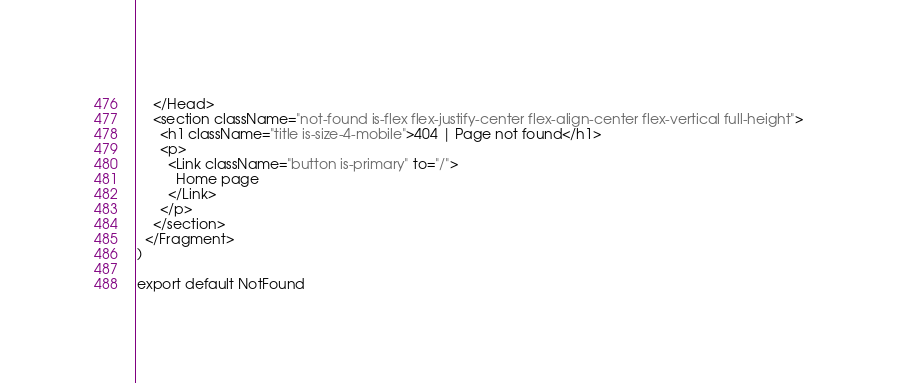<code> <loc_0><loc_0><loc_500><loc_500><_JavaScript_>    </Head>
    <section className="not-found is-flex flex-justify-center flex-align-center flex-vertical full-height">
      <h1 className="title is-size-4-mobile">404 | Page not found</h1>
      <p>
        <Link className="button is-primary" to="/">
          Home page
        </Link>
      </p>
    </section>
  </Fragment>
)

export default NotFound
</code> 